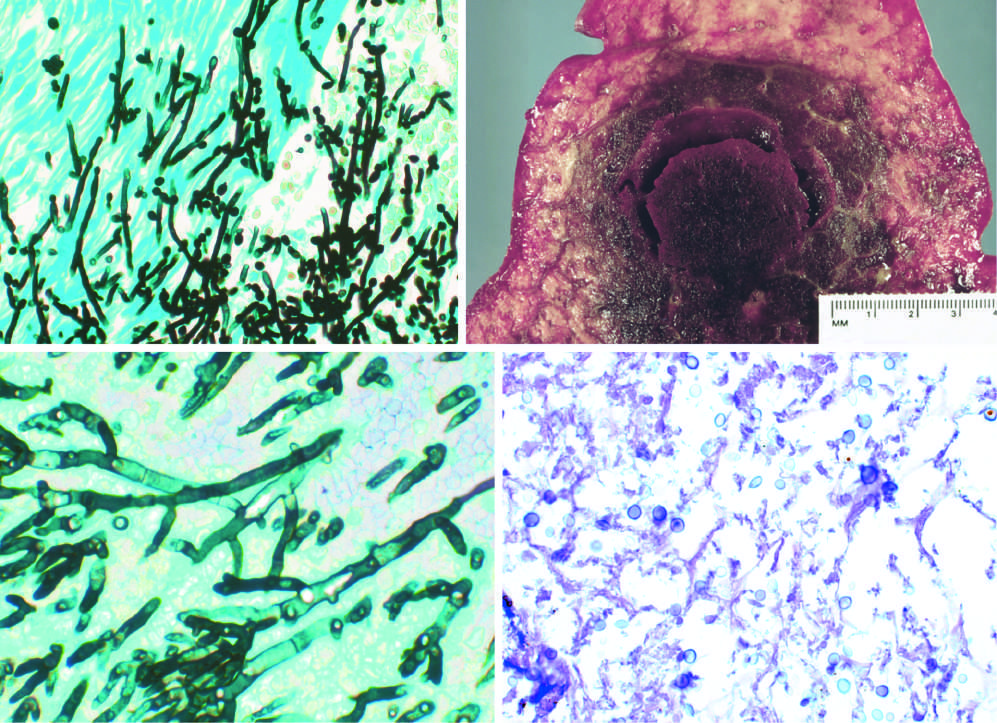what does candida organism have?
Answer the question using a single word or phrase. Pseudohyphae and budding yeasts 